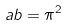Convert formula to latex. <formula><loc_0><loc_0><loc_500><loc_500>a b = \pi ^ { 2 }</formula> 